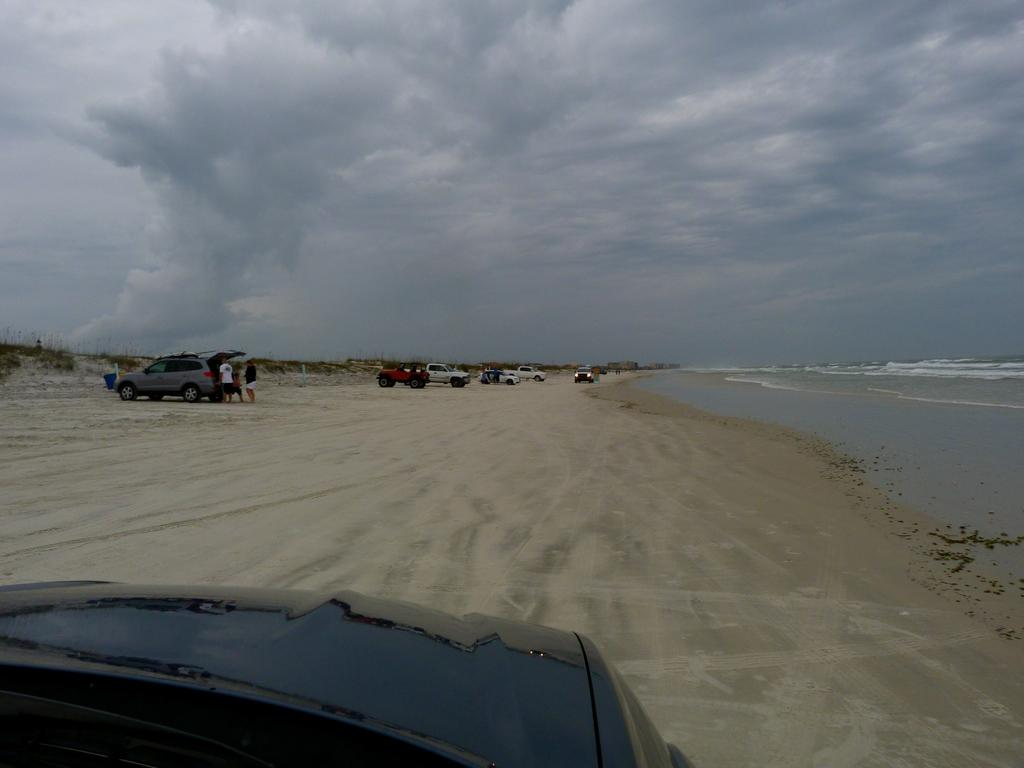What can be seen in the image? There are vehicles in the image. Where is the water located in the image? The water is in the right corner of the image. How would you describe the sky in the image? The sky is cloudy in the image. Is there a sheet covering the vehicles in the image? No, there is no sheet covering the vehicles in the image. Can you see any flies in the image? No, there are no flies present in the image. 